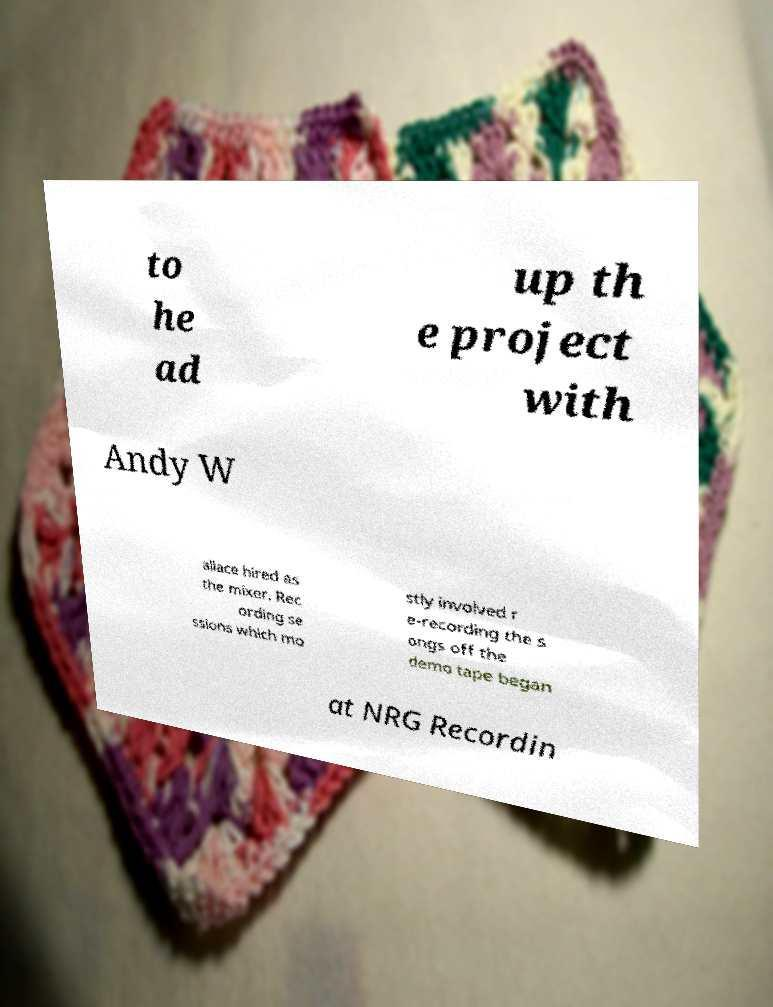Could you extract and type out the text from this image? to he ad up th e project with Andy W allace hired as the mixer. Rec ording se ssions which mo stly involved r e-recording the s ongs off the demo tape began at NRG Recordin 